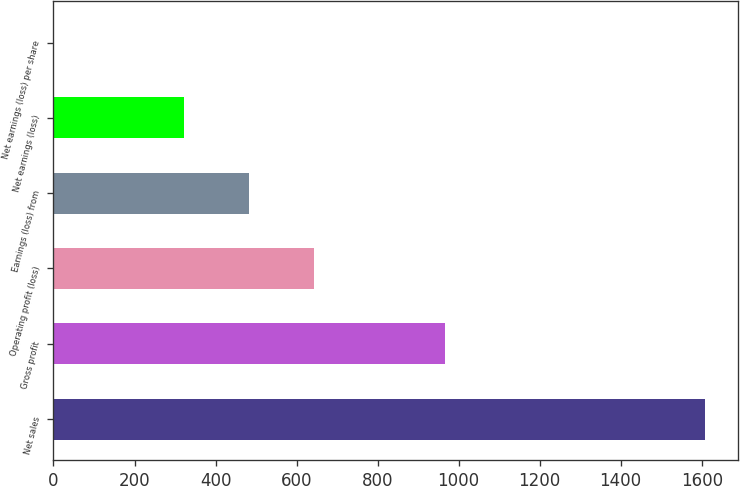Convert chart. <chart><loc_0><loc_0><loc_500><loc_500><bar_chart><fcel>Net sales<fcel>Gross profit<fcel>Operating profit (loss)<fcel>Earnings (loss) from<fcel>Net earnings (loss)<fcel>Net earnings (loss) per share<nl><fcel>1609<fcel>965.71<fcel>644.07<fcel>483.25<fcel>322.43<fcel>0.79<nl></chart> 